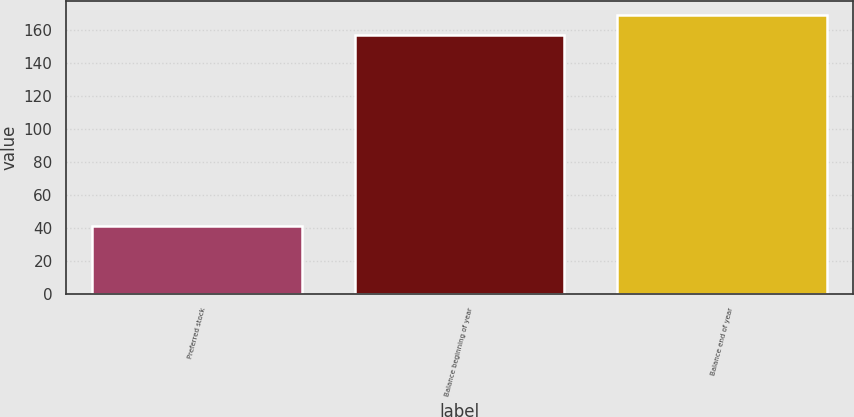Convert chart to OTSL. <chart><loc_0><loc_0><loc_500><loc_500><bar_chart><fcel>Preferred stock<fcel>Balance beginning of year<fcel>Balance end of year<nl><fcel>41<fcel>157<fcel>169.3<nl></chart> 